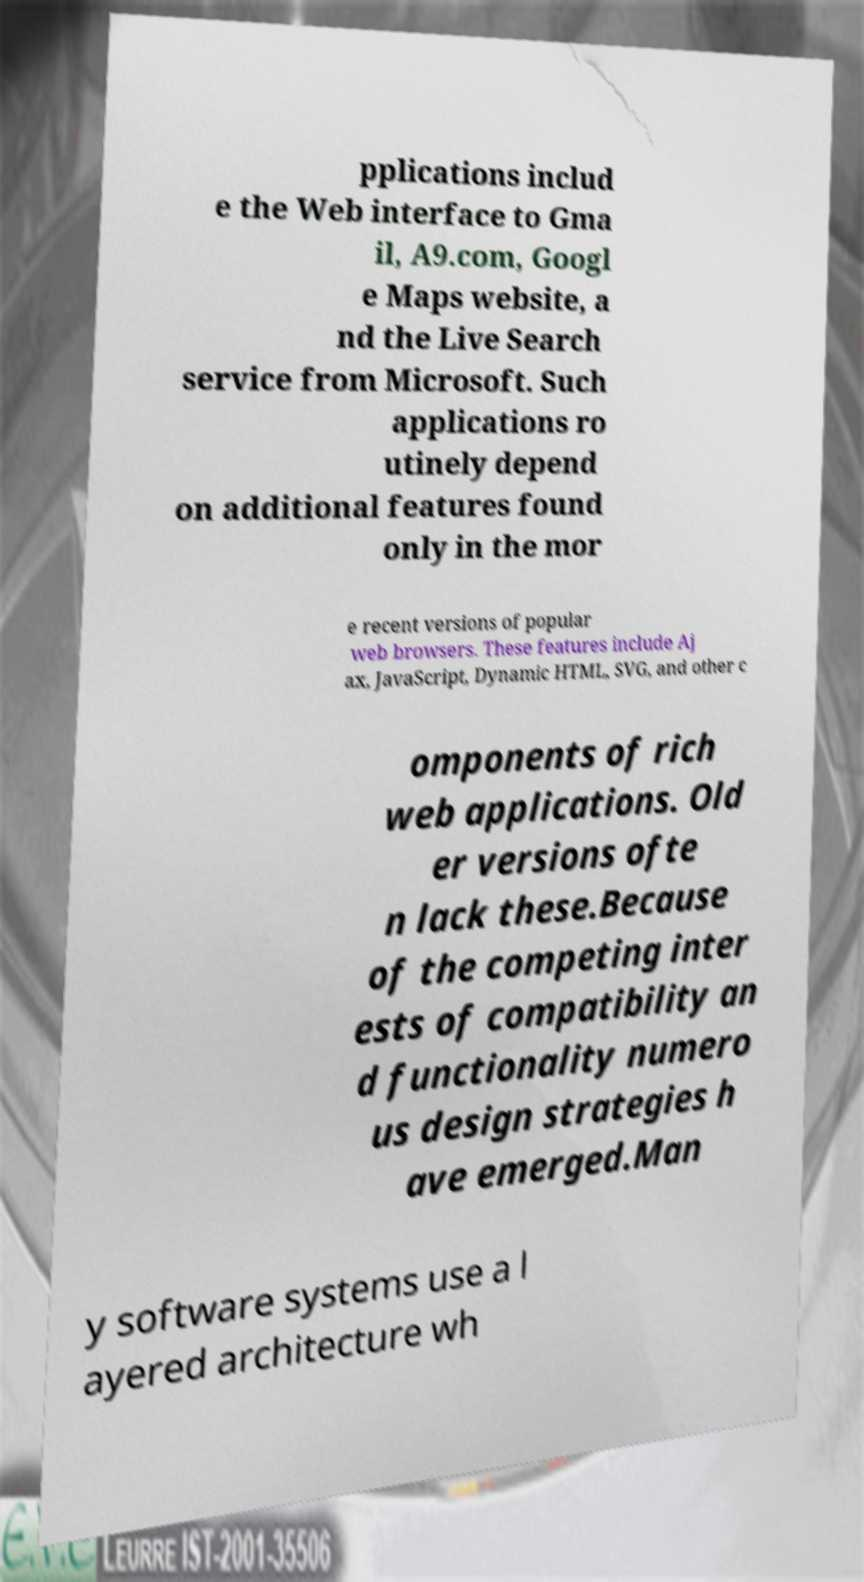Please identify and transcribe the text found in this image. pplications includ e the Web interface to Gma il, A9.com, Googl e Maps website, a nd the Live Search service from Microsoft. Such applications ro utinely depend on additional features found only in the mor e recent versions of popular web browsers. These features include Aj ax, JavaScript, Dynamic HTML, SVG, and other c omponents of rich web applications. Old er versions ofte n lack these.Because of the competing inter ests of compatibility an d functionality numero us design strategies h ave emerged.Man y software systems use a l ayered architecture wh 